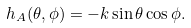Convert formula to latex. <formula><loc_0><loc_0><loc_500><loc_500>h _ { A } ( \theta , \phi ) = - k \sin \theta \cos \phi .</formula> 